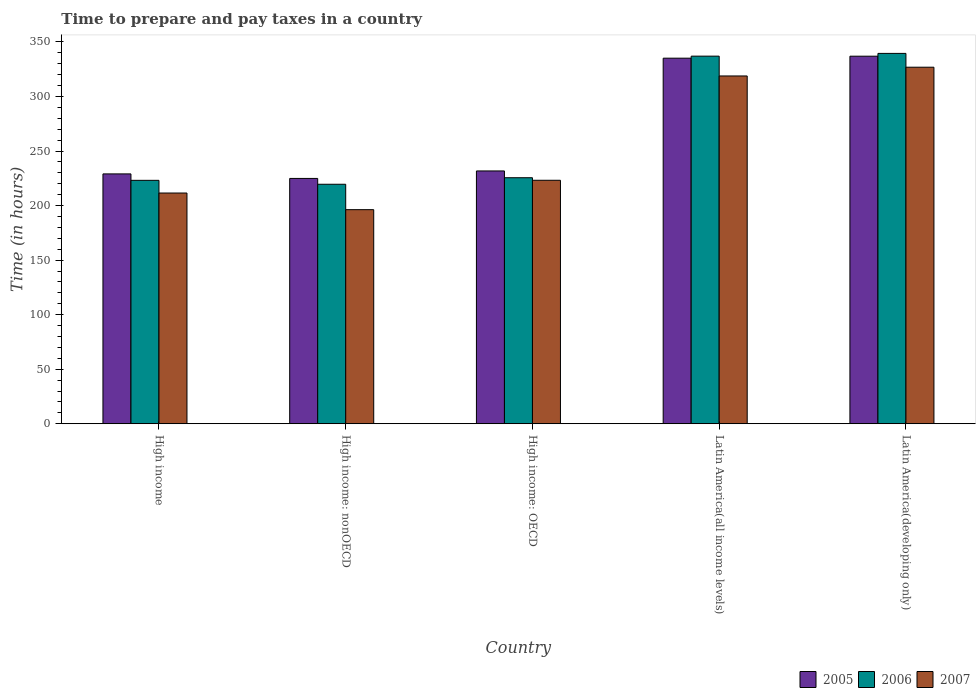How many groups of bars are there?
Your answer should be very brief. 5. Are the number of bars per tick equal to the number of legend labels?
Provide a short and direct response. Yes. Are the number of bars on each tick of the X-axis equal?
Your answer should be very brief. Yes. How many bars are there on the 3rd tick from the left?
Give a very brief answer. 3. What is the label of the 2nd group of bars from the left?
Your answer should be compact. High income: nonOECD. What is the number of hours required to prepare and pay taxes in 2006 in Latin America(all income levels)?
Make the answer very short. 337. Across all countries, what is the maximum number of hours required to prepare and pay taxes in 2006?
Your response must be concise. 339.52. Across all countries, what is the minimum number of hours required to prepare and pay taxes in 2007?
Ensure brevity in your answer.  196.26. In which country was the number of hours required to prepare and pay taxes in 2006 maximum?
Offer a very short reply. Latin America(developing only). In which country was the number of hours required to prepare and pay taxes in 2006 minimum?
Your response must be concise. High income: nonOECD. What is the total number of hours required to prepare and pay taxes in 2007 in the graph?
Offer a very short reply. 1276.66. What is the difference between the number of hours required to prepare and pay taxes in 2005 in High income: OECD and that in High income: nonOECD?
Your answer should be compact. 6.86. What is the difference between the number of hours required to prepare and pay taxes in 2005 in High income: nonOECD and the number of hours required to prepare and pay taxes in 2006 in High income: OECD?
Your answer should be compact. -0.64. What is the average number of hours required to prepare and pay taxes in 2005 per country?
Your answer should be very brief. 271.56. What is the difference between the number of hours required to prepare and pay taxes of/in 2006 and number of hours required to prepare and pay taxes of/in 2007 in Latin America(all income levels)?
Your answer should be compact. 18.17. In how many countries, is the number of hours required to prepare and pay taxes in 2007 greater than 30 hours?
Ensure brevity in your answer.  5. What is the ratio of the number of hours required to prepare and pay taxes in 2007 in High income: OECD to that in Latin America(all income levels)?
Make the answer very short. 0.7. Is the difference between the number of hours required to prepare and pay taxes in 2006 in High income and Latin America(developing only) greater than the difference between the number of hours required to prepare and pay taxes in 2007 in High income and Latin America(developing only)?
Your answer should be compact. No. What is the difference between the highest and the second highest number of hours required to prepare and pay taxes in 2007?
Provide a succinct answer. -8.02. What is the difference between the highest and the lowest number of hours required to prepare and pay taxes in 2005?
Your answer should be very brief. 112.06. What does the 1st bar from the left in Latin America(developing only) represents?
Ensure brevity in your answer.  2005. What does the 1st bar from the right in Latin America(developing only) represents?
Give a very brief answer. 2007. How many bars are there?
Provide a succinct answer. 15. How many countries are there in the graph?
Make the answer very short. 5. What is the difference between two consecutive major ticks on the Y-axis?
Your answer should be compact. 50. Does the graph contain any zero values?
Give a very brief answer. No. Does the graph contain grids?
Keep it short and to the point. No. How are the legend labels stacked?
Make the answer very short. Horizontal. What is the title of the graph?
Offer a very short reply. Time to prepare and pay taxes in a country. Does "1960" appear as one of the legend labels in the graph?
Ensure brevity in your answer.  No. What is the label or title of the Y-axis?
Your answer should be very brief. Time (in hours). What is the Time (in hours) in 2005 in High income?
Keep it short and to the point. 229.04. What is the Time (in hours) of 2006 in High income?
Make the answer very short. 223.14. What is the Time (in hours) in 2007 in High income?
Provide a short and direct response. 211.51. What is the Time (in hours) of 2005 in High income: nonOECD?
Offer a very short reply. 224.89. What is the Time (in hours) in 2006 in High income: nonOECD?
Your response must be concise. 219.55. What is the Time (in hours) in 2007 in High income: nonOECD?
Make the answer very short. 196.26. What is the Time (in hours) of 2005 in High income: OECD?
Make the answer very short. 231.76. What is the Time (in hours) of 2006 in High income: OECD?
Ensure brevity in your answer.  225.53. What is the Time (in hours) of 2007 in High income: OECD?
Give a very brief answer. 223.2. What is the Time (in hours) of 2005 in Latin America(all income levels)?
Your answer should be compact. 335.14. What is the Time (in hours) of 2006 in Latin America(all income levels)?
Your answer should be compact. 337. What is the Time (in hours) in 2007 in Latin America(all income levels)?
Your answer should be compact. 318.83. What is the Time (in hours) of 2005 in Latin America(developing only)?
Provide a succinct answer. 336.95. What is the Time (in hours) of 2006 in Latin America(developing only)?
Ensure brevity in your answer.  339.52. What is the Time (in hours) of 2007 in Latin America(developing only)?
Provide a succinct answer. 326.86. Across all countries, what is the maximum Time (in hours) in 2005?
Ensure brevity in your answer.  336.95. Across all countries, what is the maximum Time (in hours) of 2006?
Provide a succinct answer. 339.52. Across all countries, what is the maximum Time (in hours) of 2007?
Offer a very short reply. 326.86. Across all countries, what is the minimum Time (in hours) in 2005?
Offer a very short reply. 224.89. Across all countries, what is the minimum Time (in hours) in 2006?
Keep it short and to the point. 219.55. Across all countries, what is the minimum Time (in hours) of 2007?
Keep it short and to the point. 196.26. What is the total Time (in hours) of 2005 in the graph?
Provide a succinct answer. 1357.79. What is the total Time (in hours) of 2006 in the graph?
Keep it short and to the point. 1344.75. What is the total Time (in hours) in 2007 in the graph?
Offer a terse response. 1276.66. What is the difference between the Time (in hours) in 2005 in High income and that in High income: nonOECD?
Offer a terse response. 4.15. What is the difference between the Time (in hours) in 2006 in High income and that in High income: nonOECD?
Offer a terse response. 3.59. What is the difference between the Time (in hours) of 2007 in High income and that in High income: nonOECD?
Your response must be concise. 15.25. What is the difference between the Time (in hours) of 2005 in High income and that in High income: OECD?
Your response must be concise. -2.72. What is the difference between the Time (in hours) in 2006 in High income and that in High income: OECD?
Give a very brief answer. -2.39. What is the difference between the Time (in hours) in 2007 in High income and that in High income: OECD?
Keep it short and to the point. -11.69. What is the difference between the Time (in hours) of 2005 in High income and that in Latin America(all income levels)?
Offer a terse response. -106.1. What is the difference between the Time (in hours) in 2006 in High income and that in Latin America(all income levels)?
Provide a succinct answer. -113.86. What is the difference between the Time (in hours) of 2007 in High income and that in Latin America(all income levels)?
Provide a succinct answer. -107.32. What is the difference between the Time (in hours) in 2005 in High income and that in Latin America(developing only)?
Provide a succinct answer. -107.91. What is the difference between the Time (in hours) in 2006 in High income and that in Latin America(developing only)?
Offer a terse response. -116.38. What is the difference between the Time (in hours) in 2007 in High income and that in Latin America(developing only)?
Give a very brief answer. -115.35. What is the difference between the Time (in hours) of 2005 in High income: nonOECD and that in High income: OECD?
Your answer should be very brief. -6.86. What is the difference between the Time (in hours) in 2006 in High income: nonOECD and that in High income: OECD?
Offer a terse response. -5.98. What is the difference between the Time (in hours) in 2007 in High income: nonOECD and that in High income: OECD?
Your response must be concise. -26.94. What is the difference between the Time (in hours) in 2005 in High income: nonOECD and that in Latin America(all income levels)?
Give a very brief answer. -110.24. What is the difference between the Time (in hours) of 2006 in High income: nonOECD and that in Latin America(all income levels)?
Your response must be concise. -117.45. What is the difference between the Time (in hours) in 2007 in High income: nonOECD and that in Latin America(all income levels)?
Keep it short and to the point. -122.57. What is the difference between the Time (in hours) of 2005 in High income: nonOECD and that in Latin America(developing only)?
Offer a terse response. -112.06. What is the difference between the Time (in hours) in 2006 in High income: nonOECD and that in Latin America(developing only)?
Your answer should be compact. -119.97. What is the difference between the Time (in hours) of 2007 in High income: nonOECD and that in Latin America(developing only)?
Give a very brief answer. -130.6. What is the difference between the Time (in hours) in 2005 in High income: OECD and that in Latin America(all income levels)?
Provide a short and direct response. -103.38. What is the difference between the Time (in hours) of 2006 in High income: OECD and that in Latin America(all income levels)?
Your response must be concise. -111.47. What is the difference between the Time (in hours) in 2007 in High income: OECD and that in Latin America(all income levels)?
Offer a very short reply. -95.63. What is the difference between the Time (in hours) in 2005 in High income: OECD and that in Latin America(developing only)?
Give a very brief answer. -105.19. What is the difference between the Time (in hours) of 2006 in High income: OECD and that in Latin America(developing only)?
Your response must be concise. -113.99. What is the difference between the Time (in hours) in 2007 in High income: OECD and that in Latin America(developing only)?
Make the answer very short. -103.66. What is the difference between the Time (in hours) of 2005 in Latin America(all income levels) and that in Latin America(developing only)?
Provide a short and direct response. -1.81. What is the difference between the Time (in hours) in 2006 in Latin America(all income levels) and that in Latin America(developing only)?
Offer a very short reply. -2.52. What is the difference between the Time (in hours) in 2007 in Latin America(all income levels) and that in Latin America(developing only)?
Your response must be concise. -8.02. What is the difference between the Time (in hours) of 2005 in High income and the Time (in hours) of 2006 in High income: nonOECD?
Offer a very short reply. 9.49. What is the difference between the Time (in hours) of 2005 in High income and the Time (in hours) of 2007 in High income: nonOECD?
Your answer should be very brief. 32.78. What is the difference between the Time (in hours) in 2006 in High income and the Time (in hours) in 2007 in High income: nonOECD?
Give a very brief answer. 26.88. What is the difference between the Time (in hours) in 2005 in High income and the Time (in hours) in 2006 in High income: OECD?
Your answer should be compact. 3.51. What is the difference between the Time (in hours) in 2005 in High income and the Time (in hours) in 2007 in High income: OECD?
Offer a very short reply. 5.84. What is the difference between the Time (in hours) of 2006 in High income and the Time (in hours) of 2007 in High income: OECD?
Provide a succinct answer. -0.06. What is the difference between the Time (in hours) in 2005 in High income and the Time (in hours) in 2006 in Latin America(all income levels)?
Give a very brief answer. -107.96. What is the difference between the Time (in hours) in 2005 in High income and the Time (in hours) in 2007 in Latin America(all income levels)?
Make the answer very short. -89.79. What is the difference between the Time (in hours) in 2006 in High income and the Time (in hours) in 2007 in Latin America(all income levels)?
Your answer should be very brief. -95.69. What is the difference between the Time (in hours) in 2005 in High income and the Time (in hours) in 2006 in Latin America(developing only)?
Make the answer very short. -110.48. What is the difference between the Time (in hours) of 2005 in High income and the Time (in hours) of 2007 in Latin America(developing only)?
Ensure brevity in your answer.  -97.82. What is the difference between the Time (in hours) in 2006 in High income and the Time (in hours) in 2007 in Latin America(developing only)?
Your response must be concise. -103.72. What is the difference between the Time (in hours) of 2005 in High income: nonOECD and the Time (in hours) of 2006 in High income: OECD?
Offer a very short reply. -0.64. What is the difference between the Time (in hours) of 2005 in High income: nonOECD and the Time (in hours) of 2007 in High income: OECD?
Your response must be concise. 1.69. What is the difference between the Time (in hours) in 2006 in High income: nonOECD and the Time (in hours) in 2007 in High income: OECD?
Offer a very short reply. -3.65. What is the difference between the Time (in hours) of 2005 in High income: nonOECD and the Time (in hours) of 2006 in Latin America(all income levels)?
Your response must be concise. -112.11. What is the difference between the Time (in hours) in 2005 in High income: nonOECD and the Time (in hours) in 2007 in Latin America(all income levels)?
Offer a terse response. -93.94. What is the difference between the Time (in hours) in 2006 in High income: nonOECD and the Time (in hours) in 2007 in Latin America(all income levels)?
Ensure brevity in your answer.  -99.28. What is the difference between the Time (in hours) in 2005 in High income: nonOECD and the Time (in hours) in 2006 in Latin America(developing only)?
Keep it short and to the point. -114.63. What is the difference between the Time (in hours) in 2005 in High income: nonOECD and the Time (in hours) in 2007 in Latin America(developing only)?
Offer a very short reply. -101.96. What is the difference between the Time (in hours) in 2006 in High income: nonOECD and the Time (in hours) in 2007 in Latin America(developing only)?
Provide a succinct answer. -107.31. What is the difference between the Time (in hours) of 2005 in High income: OECD and the Time (in hours) of 2006 in Latin America(all income levels)?
Provide a succinct answer. -105.24. What is the difference between the Time (in hours) of 2005 in High income: OECD and the Time (in hours) of 2007 in Latin America(all income levels)?
Your answer should be very brief. -87.07. What is the difference between the Time (in hours) of 2006 in High income: OECD and the Time (in hours) of 2007 in Latin America(all income levels)?
Give a very brief answer. -93.3. What is the difference between the Time (in hours) of 2005 in High income: OECD and the Time (in hours) of 2006 in Latin America(developing only)?
Give a very brief answer. -107.77. What is the difference between the Time (in hours) of 2005 in High income: OECD and the Time (in hours) of 2007 in Latin America(developing only)?
Ensure brevity in your answer.  -95.1. What is the difference between the Time (in hours) in 2006 in High income: OECD and the Time (in hours) in 2007 in Latin America(developing only)?
Your answer should be compact. -101.32. What is the difference between the Time (in hours) in 2005 in Latin America(all income levels) and the Time (in hours) in 2006 in Latin America(developing only)?
Offer a very short reply. -4.39. What is the difference between the Time (in hours) of 2005 in Latin America(all income levels) and the Time (in hours) of 2007 in Latin America(developing only)?
Your answer should be compact. 8.28. What is the difference between the Time (in hours) of 2006 in Latin America(all income levels) and the Time (in hours) of 2007 in Latin America(developing only)?
Your response must be concise. 10.14. What is the average Time (in hours) of 2005 per country?
Ensure brevity in your answer.  271.56. What is the average Time (in hours) in 2006 per country?
Give a very brief answer. 268.95. What is the average Time (in hours) in 2007 per country?
Provide a succinct answer. 255.33. What is the difference between the Time (in hours) in 2005 and Time (in hours) in 2006 in High income?
Keep it short and to the point. 5.9. What is the difference between the Time (in hours) in 2005 and Time (in hours) in 2007 in High income?
Ensure brevity in your answer.  17.53. What is the difference between the Time (in hours) in 2006 and Time (in hours) in 2007 in High income?
Your answer should be very brief. 11.63. What is the difference between the Time (in hours) of 2005 and Time (in hours) of 2006 in High income: nonOECD?
Offer a very short reply. 5.34. What is the difference between the Time (in hours) in 2005 and Time (in hours) in 2007 in High income: nonOECD?
Provide a succinct answer. 28.63. What is the difference between the Time (in hours) in 2006 and Time (in hours) in 2007 in High income: nonOECD?
Ensure brevity in your answer.  23.29. What is the difference between the Time (in hours) in 2005 and Time (in hours) in 2006 in High income: OECD?
Your response must be concise. 6.23. What is the difference between the Time (in hours) of 2005 and Time (in hours) of 2007 in High income: OECD?
Your answer should be very brief. 8.56. What is the difference between the Time (in hours) of 2006 and Time (in hours) of 2007 in High income: OECD?
Provide a short and direct response. 2.33. What is the difference between the Time (in hours) of 2005 and Time (in hours) of 2006 in Latin America(all income levels)?
Your answer should be compact. -1.86. What is the difference between the Time (in hours) of 2005 and Time (in hours) of 2007 in Latin America(all income levels)?
Your answer should be very brief. 16.3. What is the difference between the Time (in hours) of 2006 and Time (in hours) of 2007 in Latin America(all income levels)?
Provide a short and direct response. 18.17. What is the difference between the Time (in hours) of 2005 and Time (in hours) of 2006 in Latin America(developing only)?
Offer a very short reply. -2.57. What is the difference between the Time (in hours) in 2005 and Time (in hours) in 2007 in Latin America(developing only)?
Offer a terse response. 10.1. What is the difference between the Time (in hours) of 2006 and Time (in hours) of 2007 in Latin America(developing only)?
Your answer should be compact. 12.67. What is the ratio of the Time (in hours) of 2005 in High income to that in High income: nonOECD?
Ensure brevity in your answer.  1.02. What is the ratio of the Time (in hours) in 2006 in High income to that in High income: nonOECD?
Keep it short and to the point. 1.02. What is the ratio of the Time (in hours) of 2007 in High income to that in High income: nonOECD?
Provide a short and direct response. 1.08. What is the ratio of the Time (in hours) in 2005 in High income to that in High income: OECD?
Give a very brief answer. 0.99. What is the ratio of the Time (in hours) of 2006 in High income to that in High income: OECD?
Make the answer very short. 0.99. What is the ratio of the Time (in hours) in 2007 in High income to that in High income: OECD?
Your answer should be very brief. 0.95. What is the ratio of the Time (in hours) of 2005 in High income to that in Latin America(all income levels)?
Your answer should be very brief. 0.68. What is the ratio of the Time (in hours) of 2006 in High income to that in Latin America(all income levels)?
Provide a short and direct response. 0.66. What is the ratio of the Time (in hours) of 2007 in High income to that in Latin America(all income levels)?
Offer a terse response. 0.66. What is the ratio of the Time (in hours) in 2005 in High income to that in Latin America(developing only)?
Your answer should be compact. 0.68. What is the ratio of the Time (in hours) of 2006 in High income to that in Latin America(developing only)?
Your answer should be very brief. 0.66. What is the ratio of the Time (in hours) in 2007 in High income to that in Latin America(developing only)?
Ensure brevity in your answer.  0.65. What is the ratio of the Time (in hours) in 2005 in High income: nonOECD to that in High income: OECD?
Your answer should be very brief. 0.97. What is the ratio of the Time (in hours) in 2006 in High income: nonOECD to that in High income: OECD?
Provide a short and direct response. 0.97. What is the ratio of the Time (in hours) of 2007 in High income: nonOECD to that in High income: OECD?
Provide a succinct answer. 0.88. What is the ratio of the Time (in hours) in 2005 in High income: nonOECD to that in Latin America(all income levels)?
Your answer should be very brief. 0.67. What is the ratio of the Time (in hours) in 2006 in High income: nonOECD to that in Latin America(all income levels)?
Provide a short and direct response. 0.65. What is the ratio of the Time (in hours) of 2007 in High income: nonOECD to that in Latin America(all income levels)?
Offer a terse response. 0.62. What is the ratio of the Time (in hours) of 2005 in High income: nonOECD to that in Latin America(developing only)?
Your answer should be compact. 0.67. What is the ratio of the Time (in hours) in 2006 in High income: nonOECD to that in Latin America(developing only)?
Your answer should be compact. 0.65. What is the ratio of the Time (in hours) in 2007 in High income: nonOECD to that in Latin America(developing only)?
Your answer should be very brief. 0.6. What is the ratio of the Time (in hours) in 2005 in High income: OECD to that in Latin America(all income levels)?
Your response must be concise. 0.69. What is the ratio of the Time (in hours) of 2006 in High income: OECD to that in Latin America(all income levels)?
Provide a short and direct response. 0.67. What is the ratio of the Time (in hours) in 2007 in High income: OECD to that in Latin America(all income levels)?
Provide a short and direct response. 0.7. What is the ratio of the Time (in hours) of 2005 in High income: OECD to that in Latin America(developing only)?
Your answer should be compact. 0.69. What is the ratio of the Time (in hours) in 2006 in High income: OECD to that in Latin America(developing only)?
Your response must be concise. 0.66. What is the ratio of the Time (in hours) in 2007 in High income: OECD to that in Latin America(developing only)?
Offer a terse response. 0.68. What is the ratio of the Time (in hours) in 2005 in Latin America(all income levels) to that in Latin America(developing only)?
Provide a short and direct response. 0.99. What is the ratio of the Time (in hours) in 2006 in Latin America(all income levels) to that in Latin America(developing only)?
Provide a succinct answer. 0.99. What is the ratio of the Time (in hours) in 2007 in Latin America(all income levels) to that in Latin America(developing only)?
Provide a succinct answer. 0.98. What is the difference between the highest and the second highest Time (in hours) of 2005?
Offer a very short reply. 1.81. What is the difference between the highest and the second highest Time (in hours) of 2006?
Your answer should be compact. 2.52. What is the difference between the highest and the second highest Time (in hours) in 2007?
Provide a short and direct response. 8.02. What is the difference between the highest and the lowest Time (in hours) in 2005?
Provide a succinct answer. 112.06. What is the difference between the highest and the lowest Time (in hours) in 2006?
Ensure brevity in your answer.  119.97. What is the difference between the highest and the lowest Time (in hours) of 2007?
Provide a succinct answer. 130.6. 